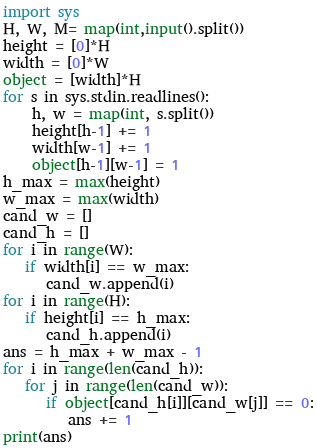Convert code to text. <code><loc_0><loc_0><loc_500><loc_500><_Python_>import sys
H, W, M= map(int,input().split())
height = [0]*H
width = [0]*W
object = [width]*H
for s in sys.stdin.readlines():
    h, w = map(int, s.split())
    height[h-1] += 1
    width[w-1] += 1
    object[h-1][w-1] = 1
h_max = max(height)
w_max = max(width)
cand_w = []
cand_h = []
for i in range(W):
   if width[i] == w_max:
      cand_w.append(i)
for i in range(H):
   if height[i] == h_max:
      cand_h.append(i)
ans = h_max + w_max - 1
for i in range(len(cand_h)):
   for j in range(len(cand_w)):
      if object[cand_h[i]][cand_w[j]] == 0:
         ans += 1
print(ans) </code> 